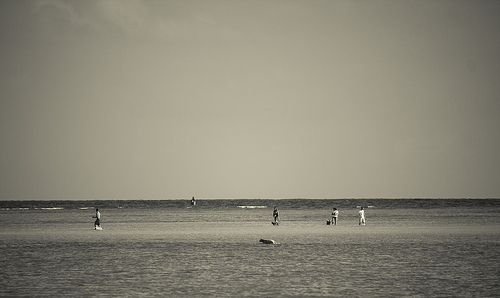a person in walking. On the beach's vast expanse, a person walking would likely be positioned in isolation, with their stride and shadow casting an elongated figure against the sand. 